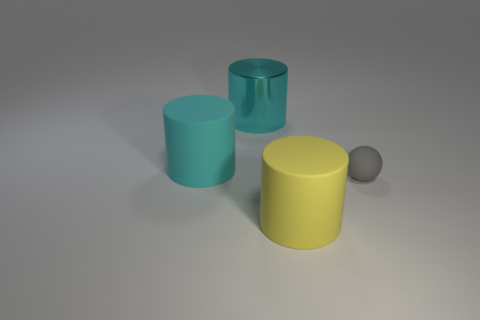Does the big matte thing on the right side of the large cyan metallic cylinder have the same shape as the tiny rubber object? no 